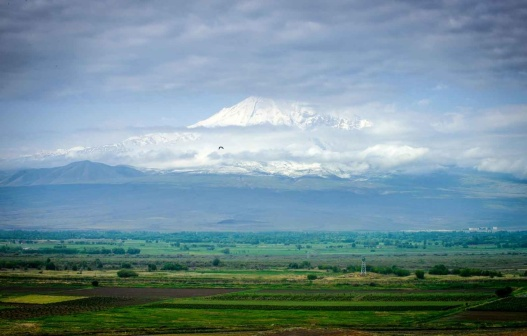Imagine you are a poet in this landscape. Write a poem inspired by what you see. Beneath the azure sky’s expanse,
A mountain stands, its peak entranced,
In snowy garb and cloud’s embrace,
A timeless titan’s stoic grace.

The verdant valley, lush and green,
A living tapestry serene,
Where trees and fields in hues so bright,
Kiss the horizon’s soft light.

Oh, how the clouds do wisp and weave,
Tales of old they subtly leave,
In this tranquil, pristine frame,
Nature’s glory, pure and tame. 